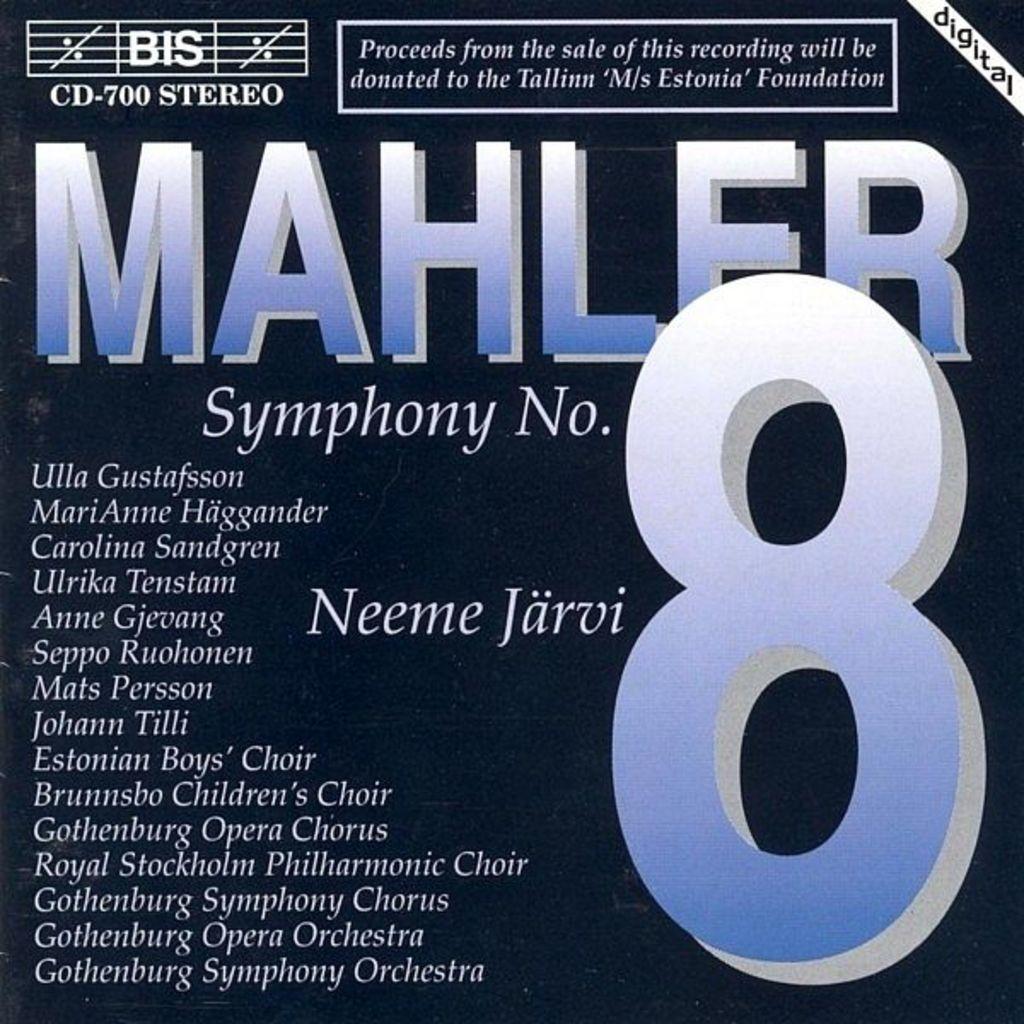What is the ad for?
Your answer should be very brief. Mahler symphony 8. Which symphony is this?
Your response must be concise. 8. 